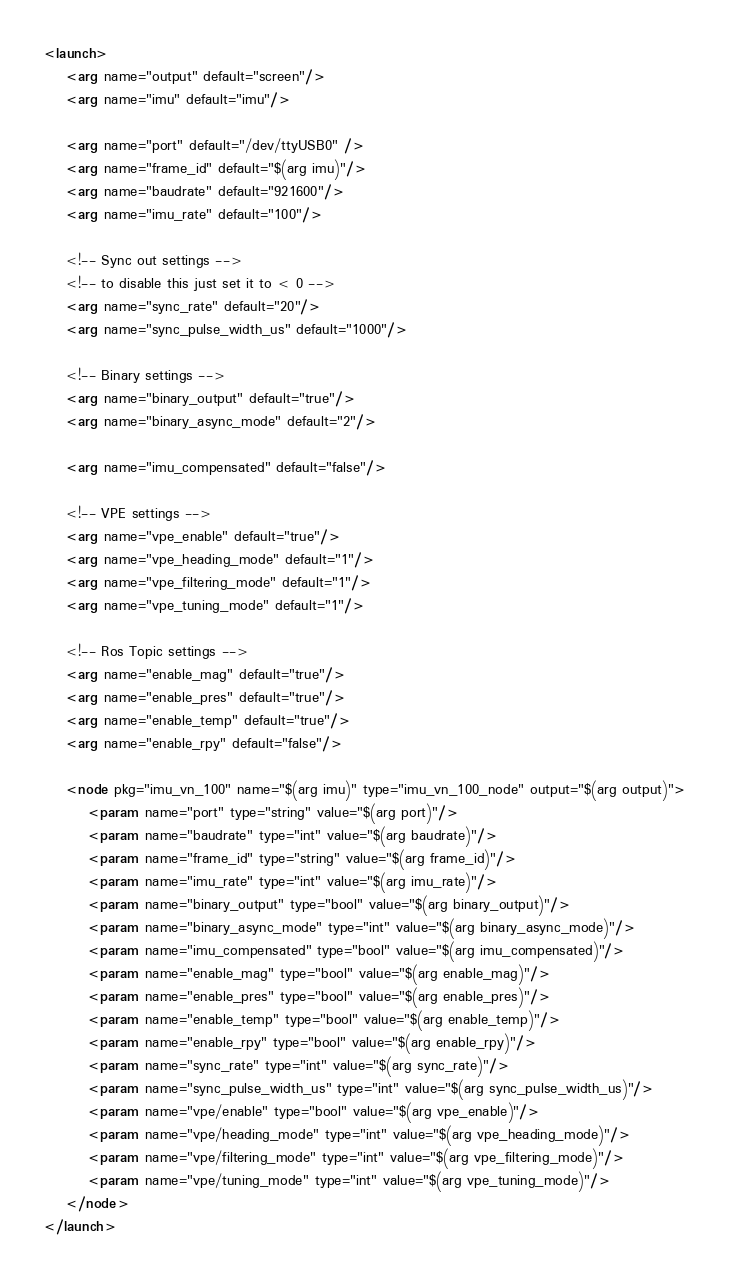<code> <loc_0><loc_0><loc_500><loc_500><_XML_><launch>
    <arg name="output" default="screen"/>
    <arg name="imu" default="imu"/>

    <arg name="port" default="/dev/ttyUSB0" />
    <arg name="frame_id" default="$(arg imu)"/>
    <arg name="baudrate" default="921600"/>
    <arg name="imu_rate" default="100"/>

    <!-- Sync out settings -->
    <!-- to disable this just set it to < 0 -->
    <arg name="sync_rate" default="20"/>
    <arg name="sync_pulse_width_us" default="1000"/>

    <!-- Binary settings -->
    <arg name="binary_output" default="true"/>
    <arg name="binary_async_mode" default="2"/>

    <arg name="imu_compensated" default="false"/>

    <!-- VPE settings -->
    <arg name="vpe_enable" default="true"/>
    <arg name="vpe_heading_mode" default="1"/>
    <arg name="vpe_filtering_mode" default="1"/>
    <arg name="vpe_tuning_mode" default="1"/>

    <!-- Ros Topic settings -->
    <arg name="enable_mag" default="true"/>
    <arg name="enable_pres" default="true"/>
    <arg name="enable_temp" default="true"/>
    <arg name="enable_rpy" default="false"/>

    <node pkg="imu_vn_100" name="$(arg imu)" type="imu_vn_100_node" output="$(arg output)">
        <param name="port" type="string" value="$(arg port)"/>
        <param name="baudrate" type="int" value="$(arg baudrate)"/>
        <param name="frame_id" type="string" value="$(arg frame_id)"/>
        <param name="imu_rate" type="int" value="$(arg imu_rate)"/>
        <param name="binary_output" type="bool" value="$(arg binary_output)"/>
        <param name="binary_async_mode" type="int" value="$(arg binary_async_mode)"/>
        <param name="imu_compensated" type="bool" value="$(arg imu_compensated)"/>
        <param name="enable_mag" type="bool" value="$(arg enable_mag)"/>
        <param name="enable_pres" type="bool" value="$(arg enable_pres)"/>
        <param name="enable_temp" type="bool" value="$(arg enable_temp)"/>
        <param name="enable_rpy" type="bool" value="$(arg enable_rpy)"/>
        <param name="sync_rate" type="int" value="$(arg sync_rate)"/>
        <param name="sync_pulse_width_us" type="int" value="$(arg sync_pulse_width_us)"/>
        <param name="vpe/enable" type="bool" value="$(arg vpe_enable)"/>
        <param name="vpe/heading_mode" type="int" value="$(arg vpe_heading_mode)"/>
        <param name="vpe/filtering_mode" type="int" value="$(arg vpe_filtering_mode)"/>
        <param name="vpe/tuning_mode" type="int" value="$(arg vpe_tuning_mode)"/>
    </node>
</launch>
</code> 